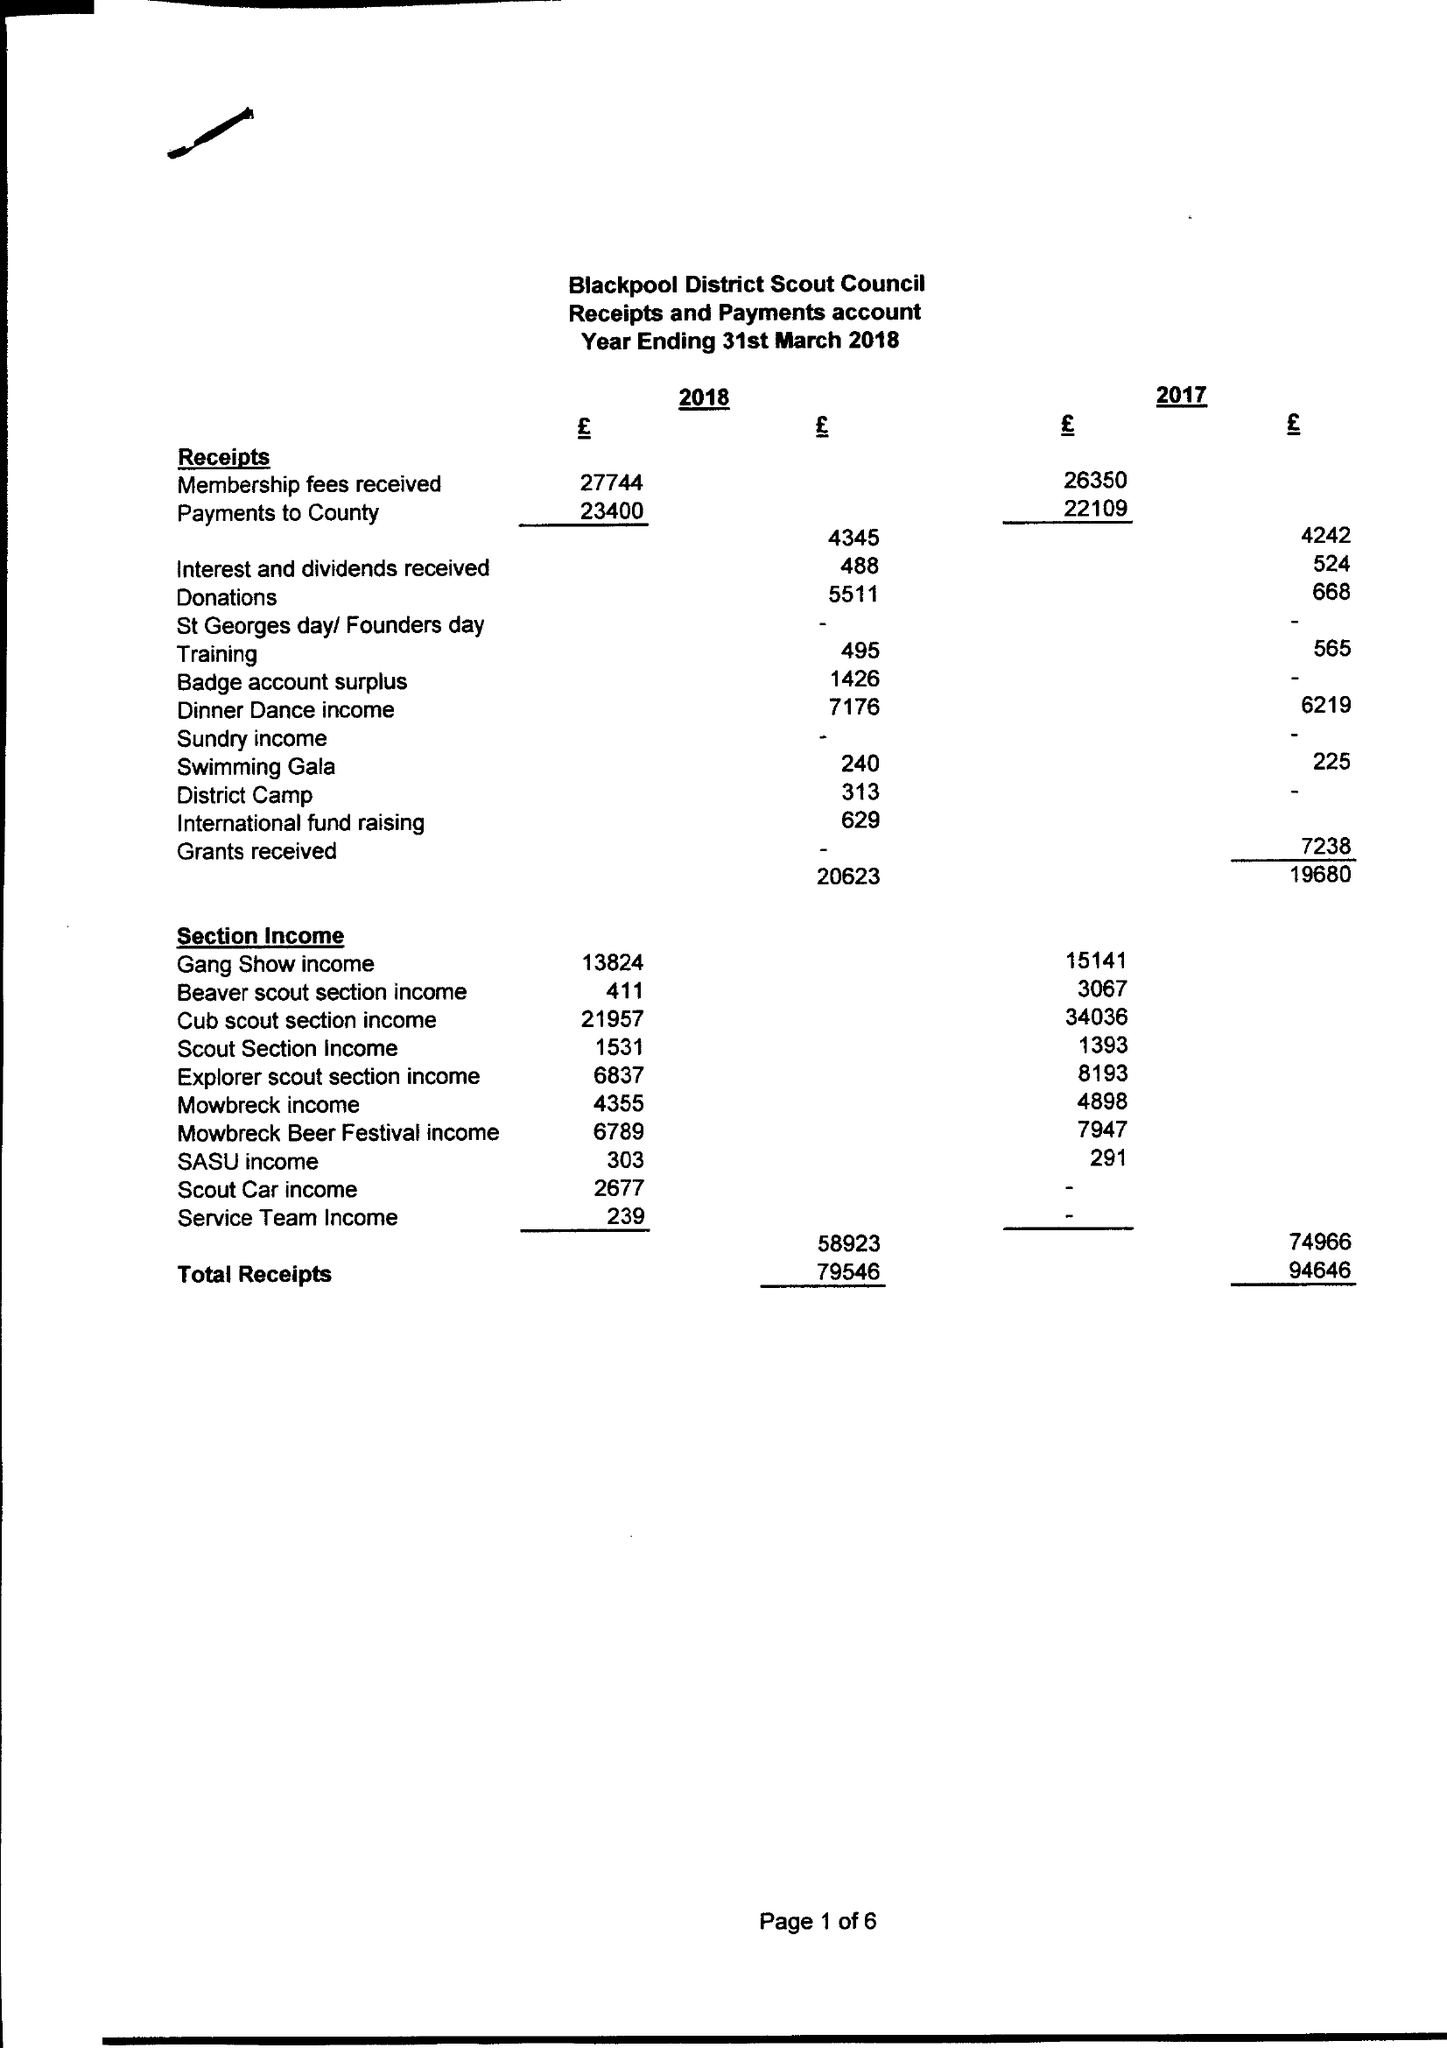What is the value for the spending_annually_in_british_pounds?
Answer the question using a single word or phrase. 73404.00 